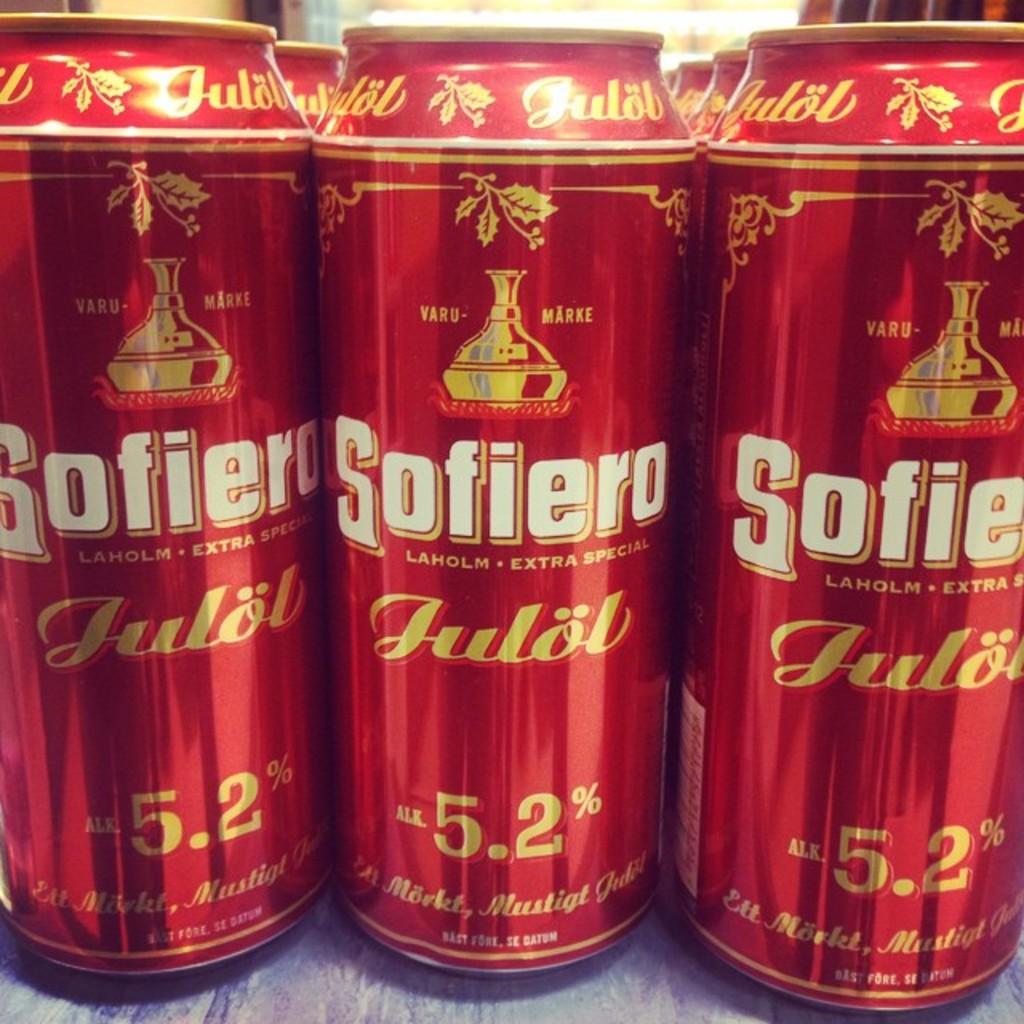What is the alcohol percentage?
Offer a terse response. 5.2%. What brand of alchohol is this?
Provide a short and direct response. Sofiero. 